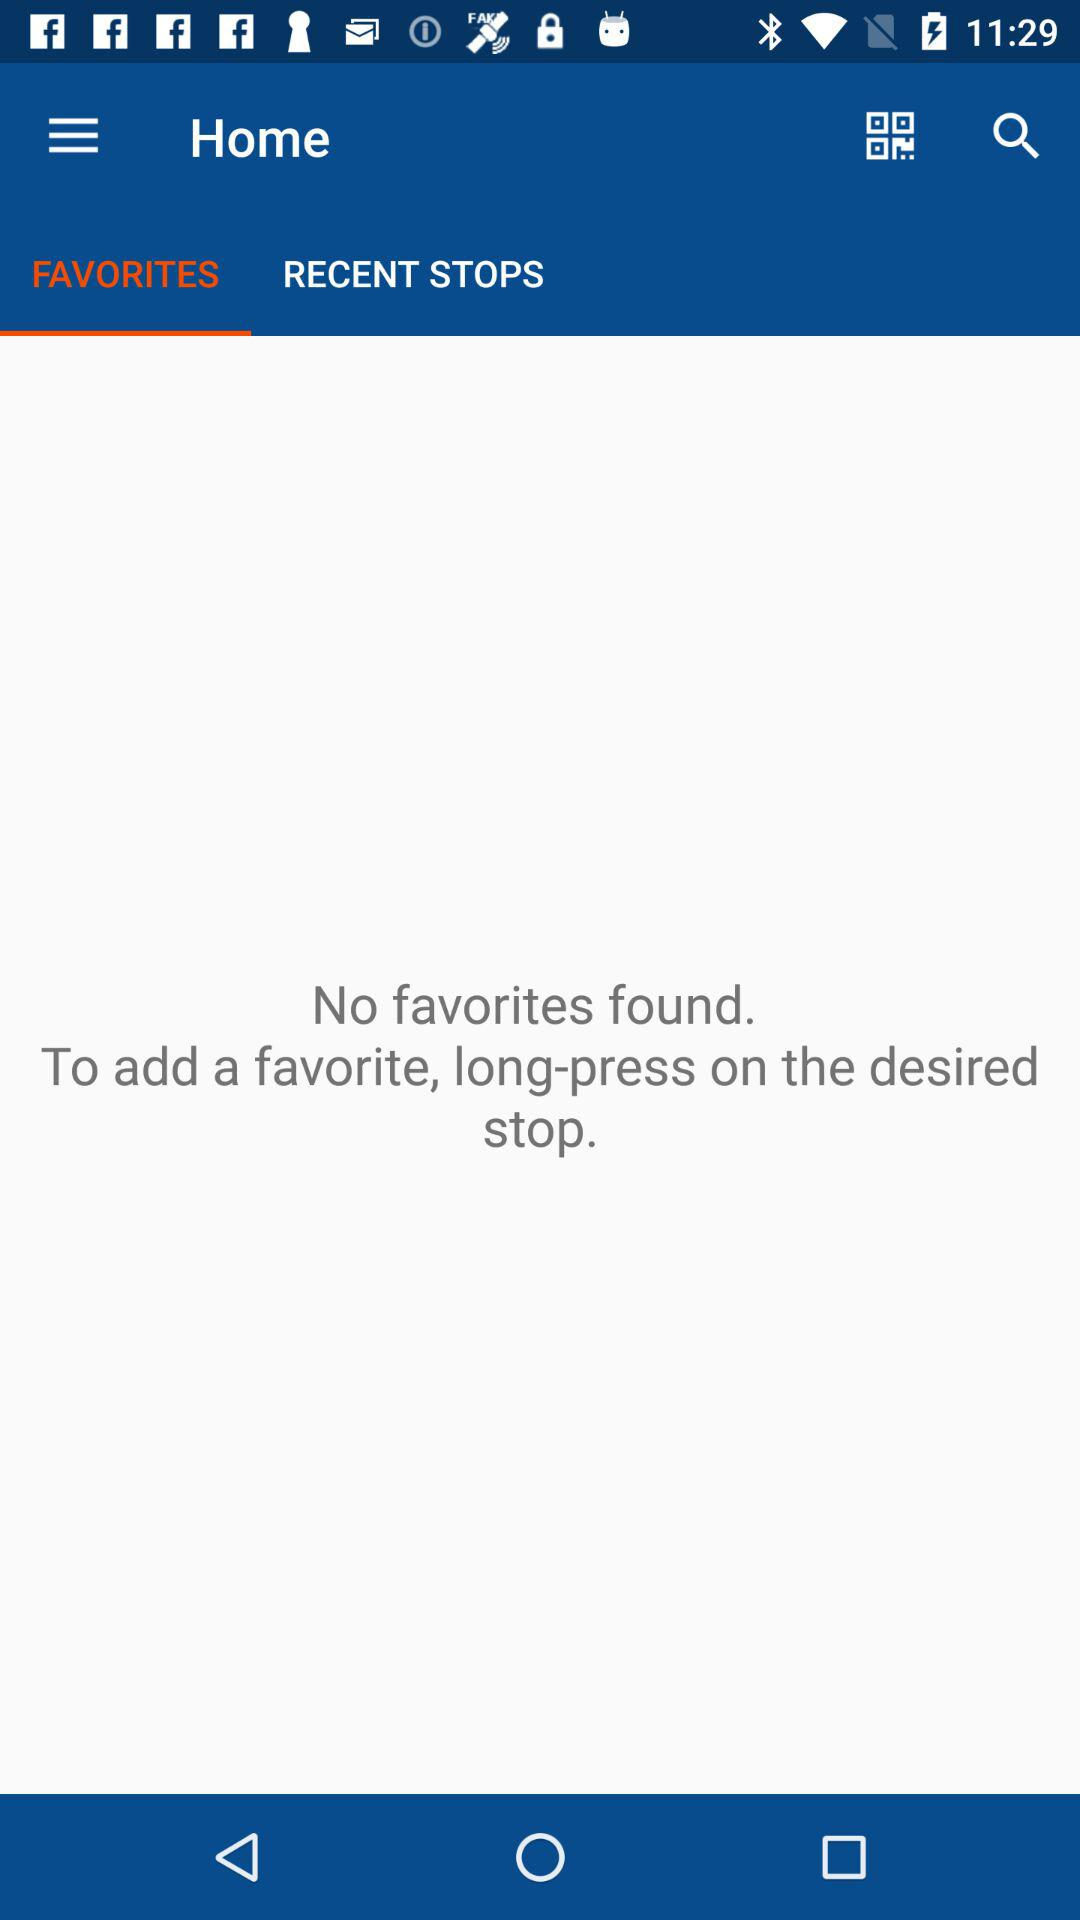Which tab is selected? The selected tab is Favorites. 